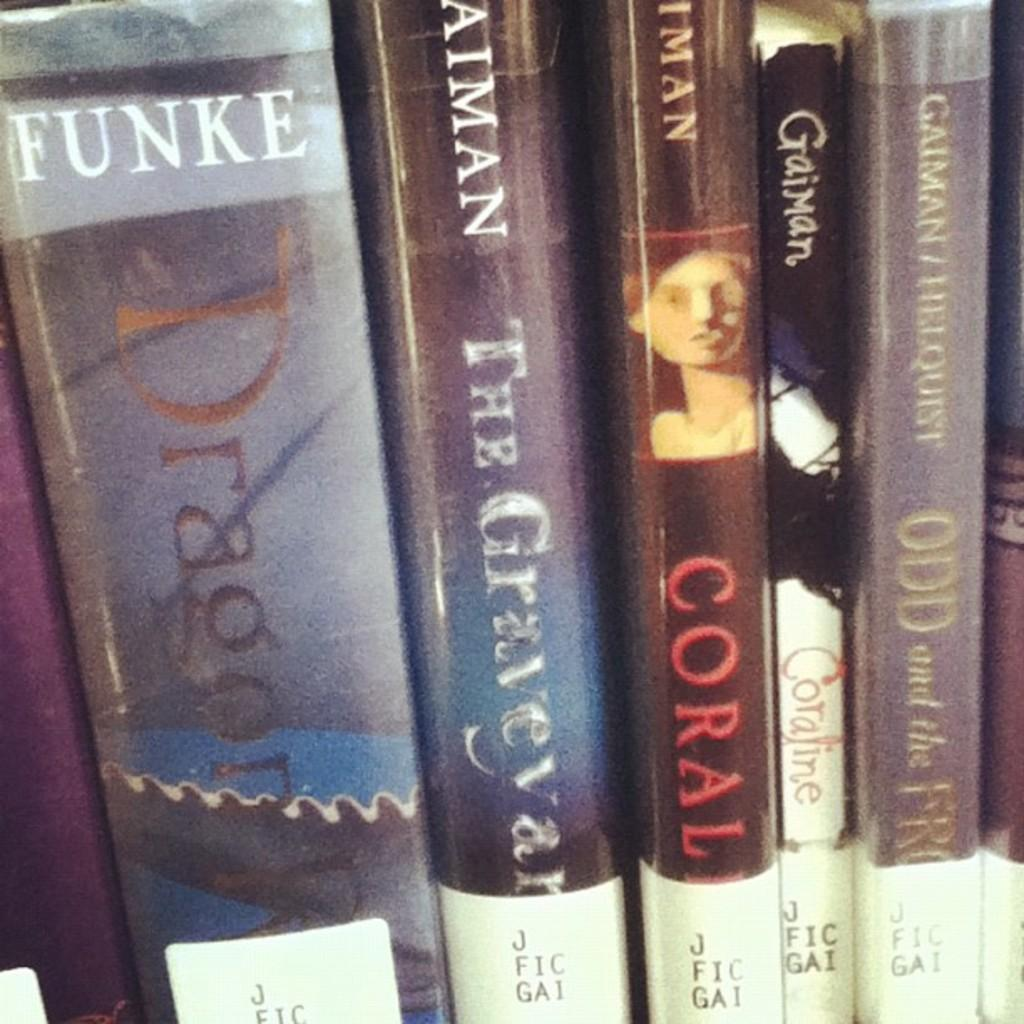Provide a one-sentence caption for the provided image. Many books at the library, the largest is called Dragon. 